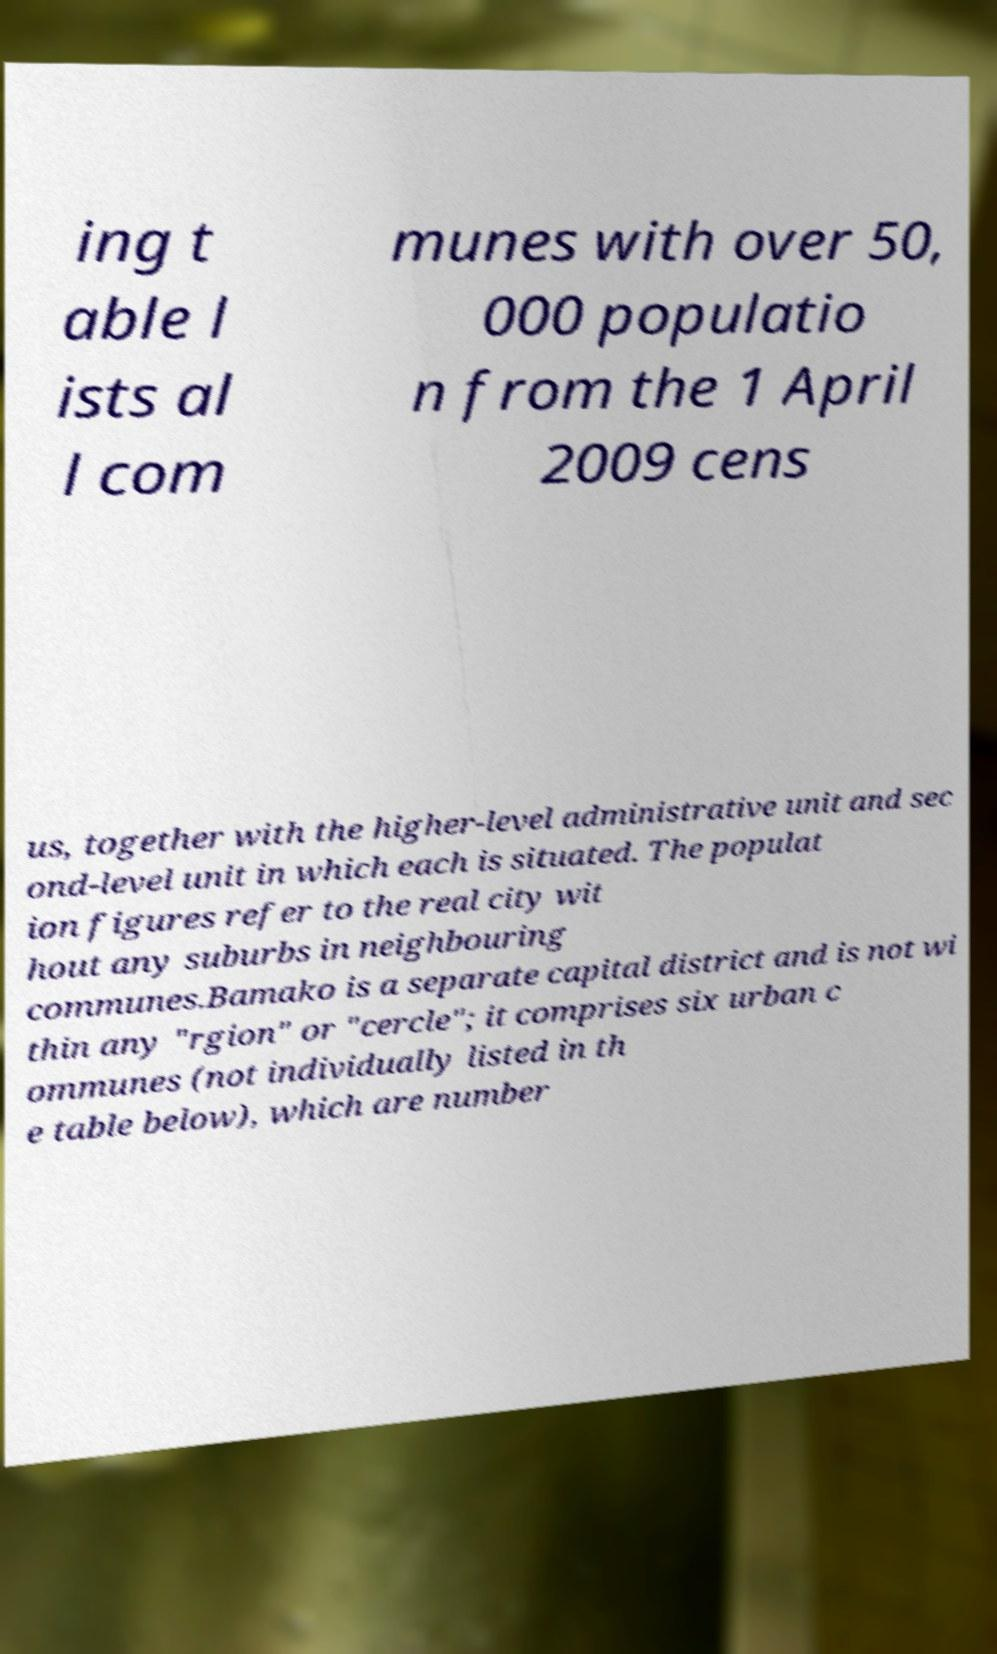Please identify and transcribe the text found in this image. ing t able l ists al l com munes with over 50, 000 populatio n from the 1 April 2009 cens us, together with the higher-level administrative unit and sec ond-level unit in which each is situated. The populat ion figures refer to the real city wit hout any suburbs in neighbouring communes.Bamako is a separate capital district and is not wi thin any "rgion" or "cercle"; it comprises six urban c ommunes (not individually listed in th e table below), which are number 